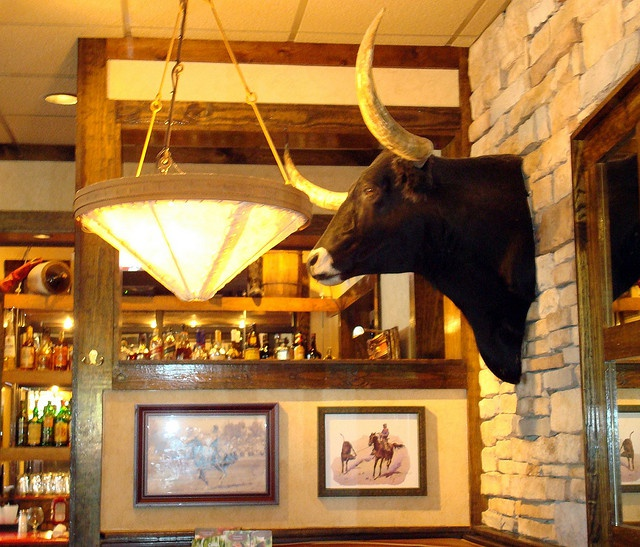Describe the objects in this image and their specific colors. I can see bottle in orange, maroon, and brown tones, bottle in orange, red, and maroon tones, bottle in orange, brown, maroon, and red tones, bottle in orange, black, olive, and maroon tones, and bottle in orange, black, maroon, and olive tones in this image. 